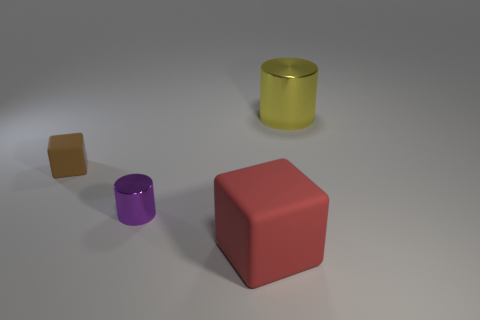Is there anything else that has the same color as the tiny matte object?
Offer a terse response. No. How many red rubber cubes are there?
Provide a short and direct response. 1. What is the large object to the left of the thing that is right of the big matte block made of?
Provide a succinct answer. Rubber. There is a rubber cube that is on the left side of the rubber object that is in front of the metallic cylinder to the left of the red object; what is its color?
Ensure brevity in your answer.  Brown. What number of cubes are the same size as the brown rubber thing?
Offer a terse response. 0. Are there more big yellow shiny things that are behind the tiny purple thing than tiny blocks that are to the left of the tiny brown cube?
Offer a terse response. Yes. What color is the shiny cylinder on the right side of the metal cylinder that is in front of the big cylinder?
Offer a very short reply. Yellow. Is the material of the red cube the same as the large yellow cylinder?
Keep it short and to the point. No. Is there another tiny purple object that has the same shape as the tiny purple shiny thing?
Your response must be concise. No. Does the matte block that is behind the big matte cube have the same size as the metal thing that is in front of the tiny matte cube?
Make the answer very short. Yes. 